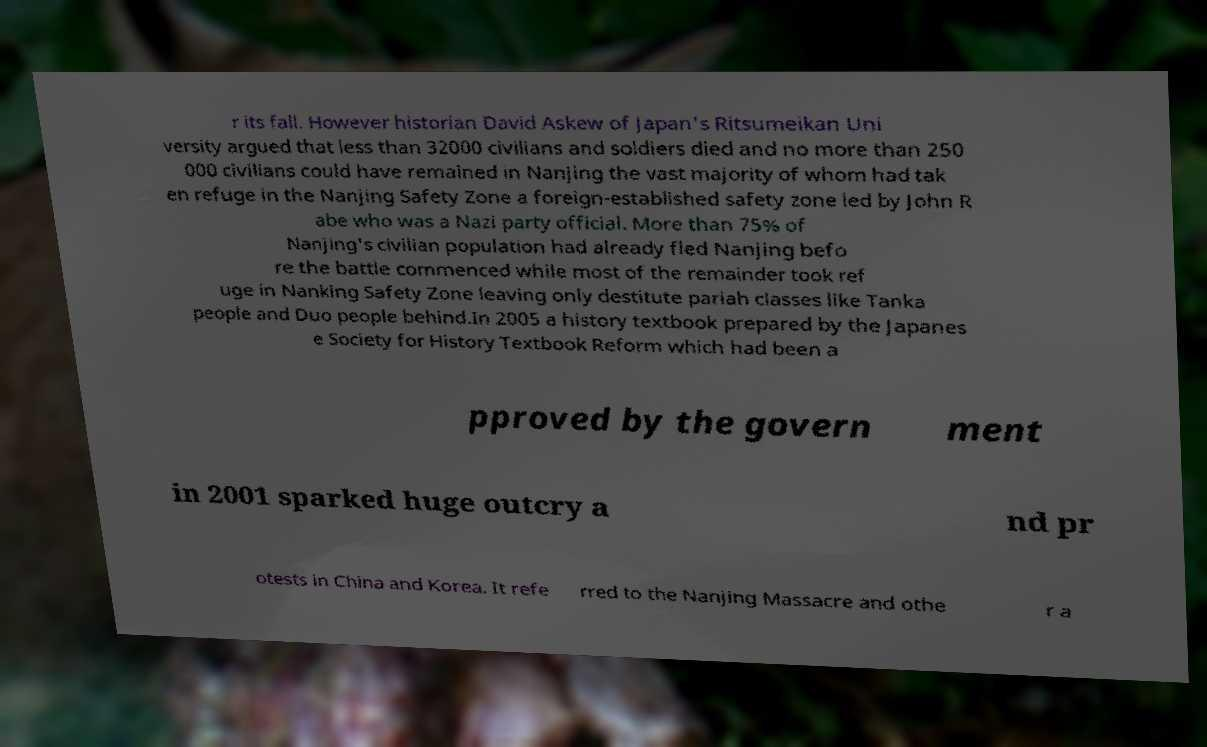Could you assist in decoding the text presented in this image and type it out clearly? r its fall. However historian David Askew of Japan's Ritsumeikan Uni versity argued that less than 32000 civilians and soldiers died and no more than 250 000 civilians could have remained in Nanjing the vast majority of whom had tak en refuge in the Nanjing Safety Zone a foreign-established safety zone led by John R abe who was a Nazi party official. More than 75% of Nanjing's civilian population had already fled Nanjing befo re the battle commenced while most of the remainder took ref uge in Nanking Safety Zone leaving only destitute pariah classes like Tanka people and Duo people behind.In 2005 a history textbook prepared by the Japanes e Society for History Textbook Reform which had been a pproved by the govern ment in 2001 sparked huge outcry a nd pr otests in China and Korea. It refe rred to the Nanjing Massacre and othe r a 